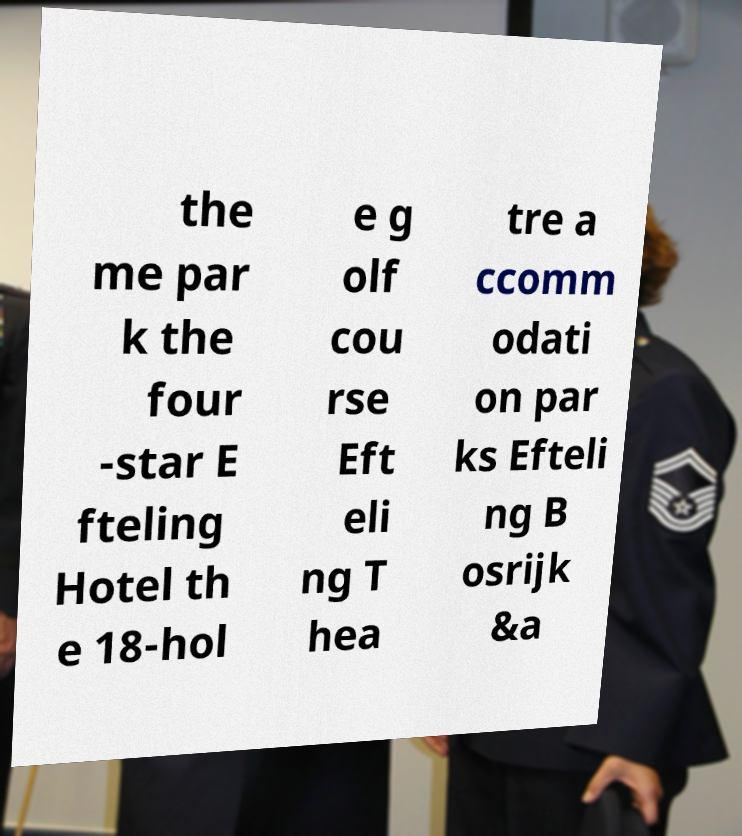Please identify and transcribe the text found in this image. the me par k the four -star E fteling Hotel th e 18-hol e g olf cou rse Eft eli ng T hea tre a ccomm odati on par ks Efteli ng B osrijk &a 